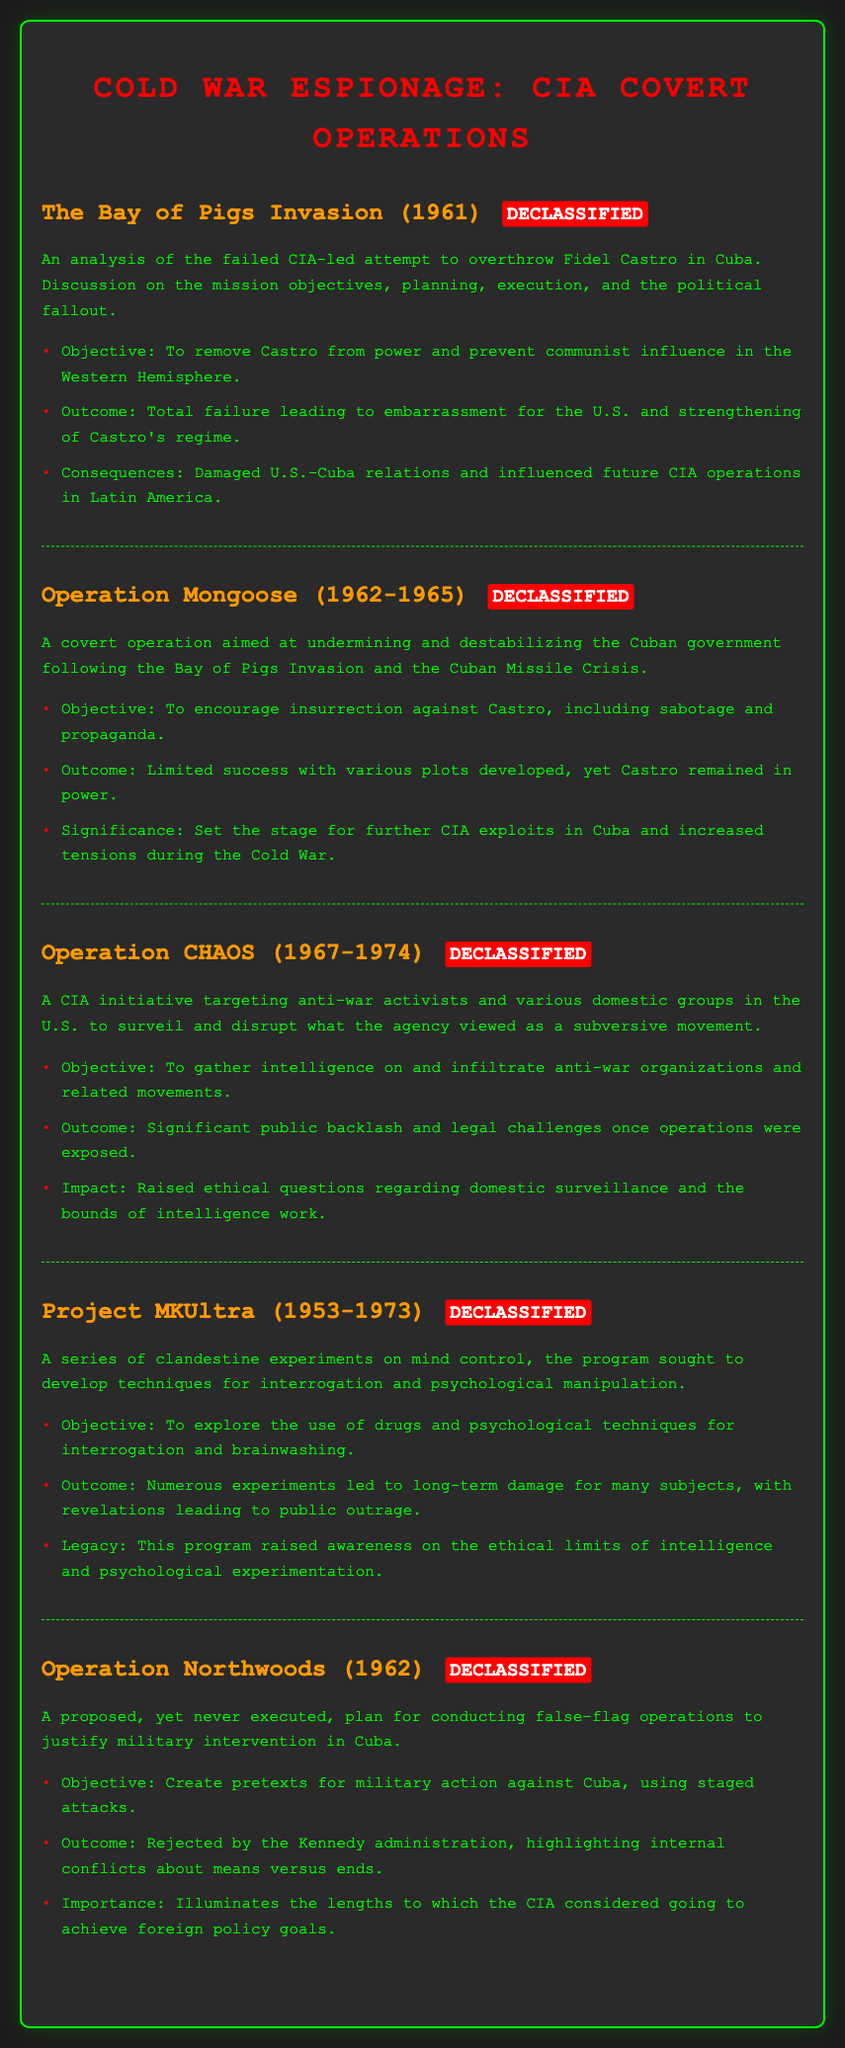What was the objective of the Bay of Pigs Invasion? The objective was to remove Castro from power and prevent communist influence in the Western Hemisphere.
Answer: To remove Castro from power and prevent communist influence in the Western Hemisphere What years did Operation Mongoose take place? Operation Mongoose occurred from 1962 to 1965.
Answer: 1962-1965 What was the outcome of Operation CHAOS? The outcome was significant public backlash and legal challenges once operations were exposed.
Answer: Significant public backlash and legal challenges What was the main focus of Project MKUltra? The main focus was to explore the use of drugs and psychological techniques for interrogation and brainwashing.
Answer: To explore the use of drugs and psychological techniques for interrogation and brainwashing What was the proposed objective of Operation Northwoods? The objective was to create pretexts for military action against Cuba, using staged attacks.
Answer: To create pretexts for military action against Cuba, using staged attacks Which operation aimed to destabilize the Cuban government after the Bay of Pigs? The operation that aimed to destabilize the Cuban government was Operation Mongoose.
Answer: Operation Mongoose What consequence arose from the Bay of Pigs Invasion? The consequence was damaged U.S.-Cuba relations and influenced future CIA operations in Latin America.
Answer: Damaged U.S.-Cuba relations and influenced future CIA operations in Latin America What was the legacy of Project MKUltra? The legacy was raised awareness on the ethical limits of intelligence and psychological experimentation.
Answer: Raised awareness on the ethical limits of intelligence and psychological experimentation 